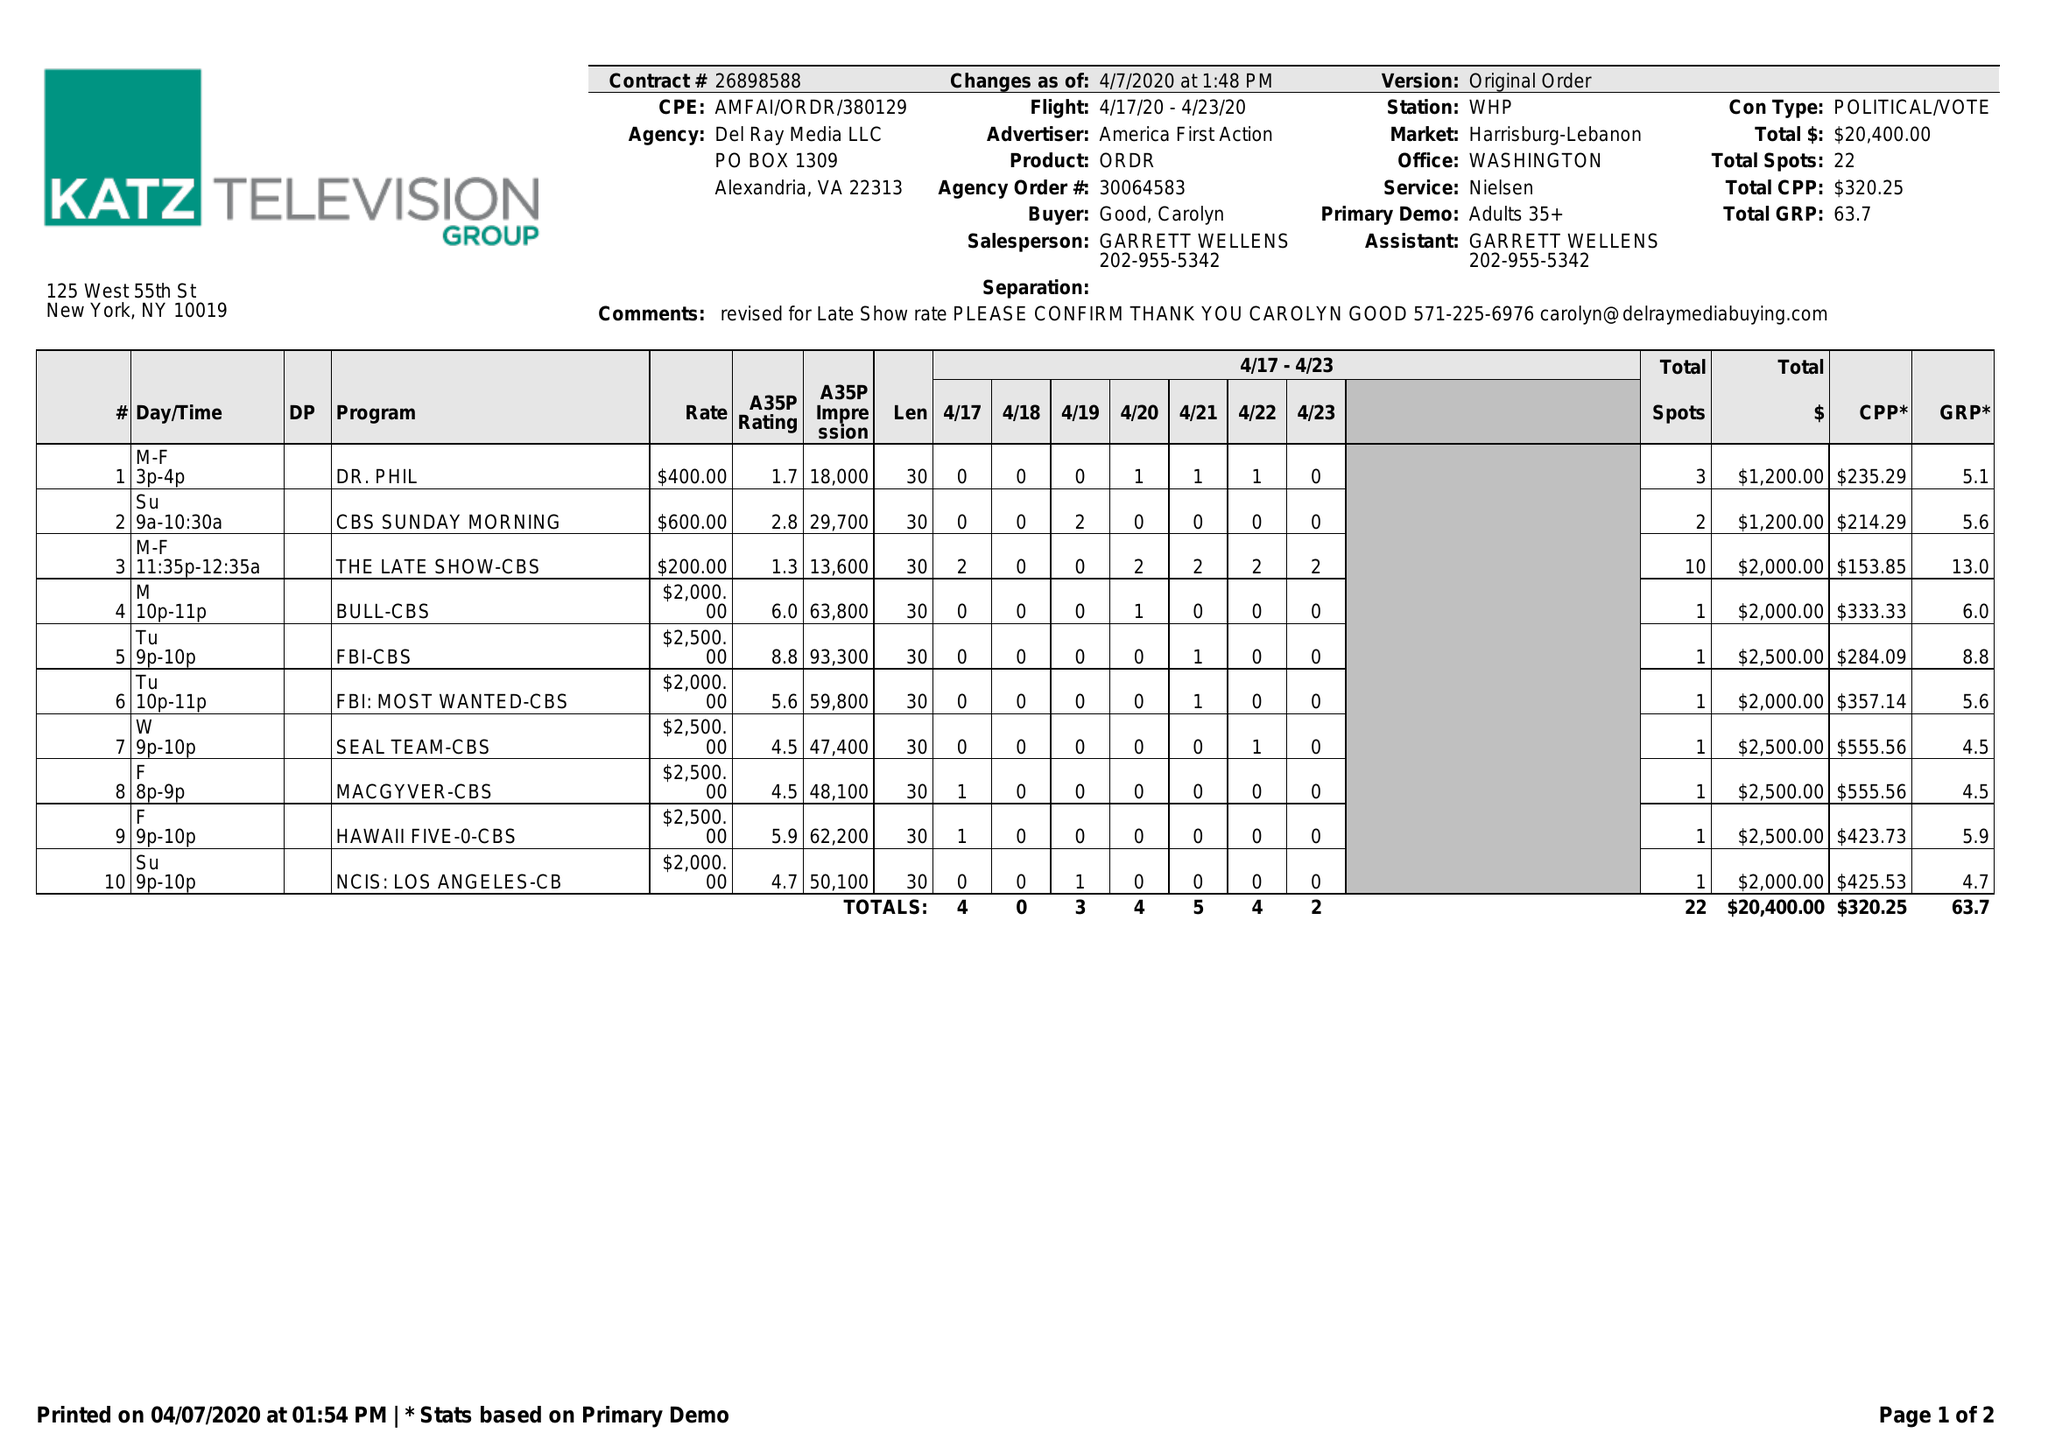What is the value for the advertiser?
Answer the question using a single word or phrase. AMERICA FIRST ACTION 